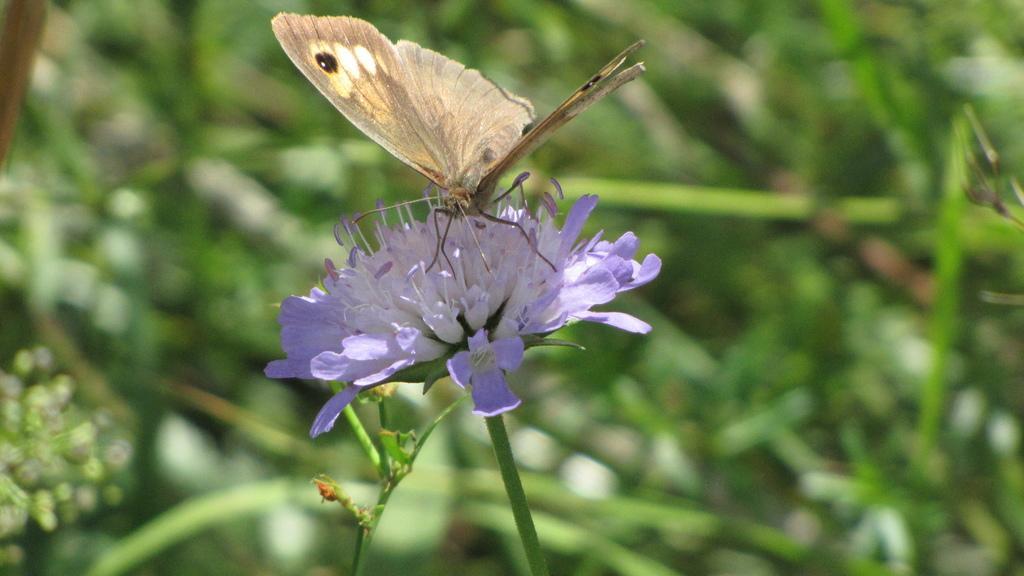Please provide a concise description of this image. In this image I can see the white and purple color flower to the plant. I can see the brown and cream color butterfly on the flower. In the background I can see few more plants but the background is blurred. 